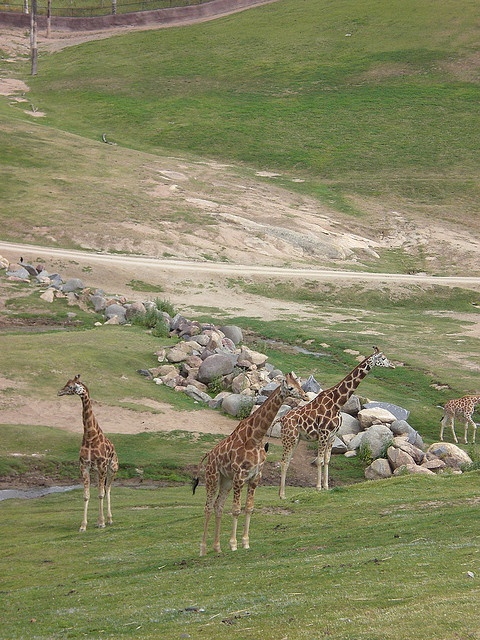Describe the objects in this image and their specific colors. I can see giraffe in olive and gray tones, giraffe in olive, gray, darkgray, and maroon tones, giraffe in olive and gray tones, and giraffe in olive, gray, and darkgray tones in this image. 